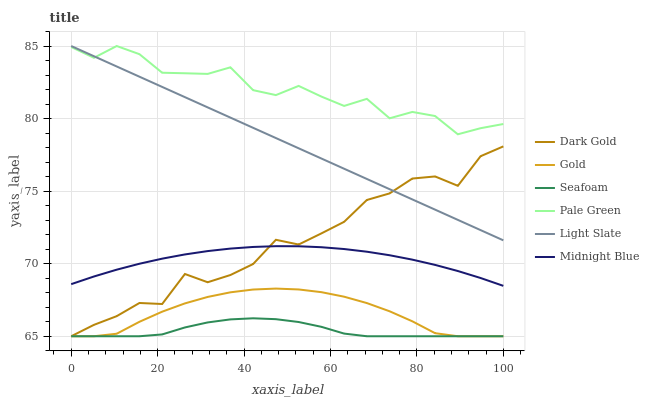Does Seafoam have the minimum area under the curve?
Answer yes or no. Yes. Does Pale Green have the maximum area under the curve?
Answer yes or no. Yes. Does Gold have the minimum area under the curve?
Answer yes or no. No. Does Gold have the maximum area under the curve?
Answer yes or no. No. Is Light Slate the smoothest?
Answer yes or no. Yes. Is Dark Gold the roughest?
Answer yes or no. Yes. Is Gold the smoothest?
Answer yes or no. No. Is Gold the roughest?
Answer yes or no. No. Does Gold have the lowest value?
Answer yes or no. Yes. Does Light Slate have the lowest value?
Answer yes or no. No. Does Pale Green have the highest value?
Answer yes or no. Yes. Does Gold have the highest value?
Answer yes or no. No. Is Dark Gold less than Pale Green?
Answer yes or no. Yes. Is Midnight Blue greater than Gold?
Answer yes or no. Yes. Does Pale Green intersect Light Slate?
Answer yes or no. Yes. Is Pale Green less than Light Slate?
Answer yes or no. No. Is Pale Green greater than Light Slate?
Answer yes or no. No. Does Dark Gold intersect Pale Green?
Answer yes or no. No. 